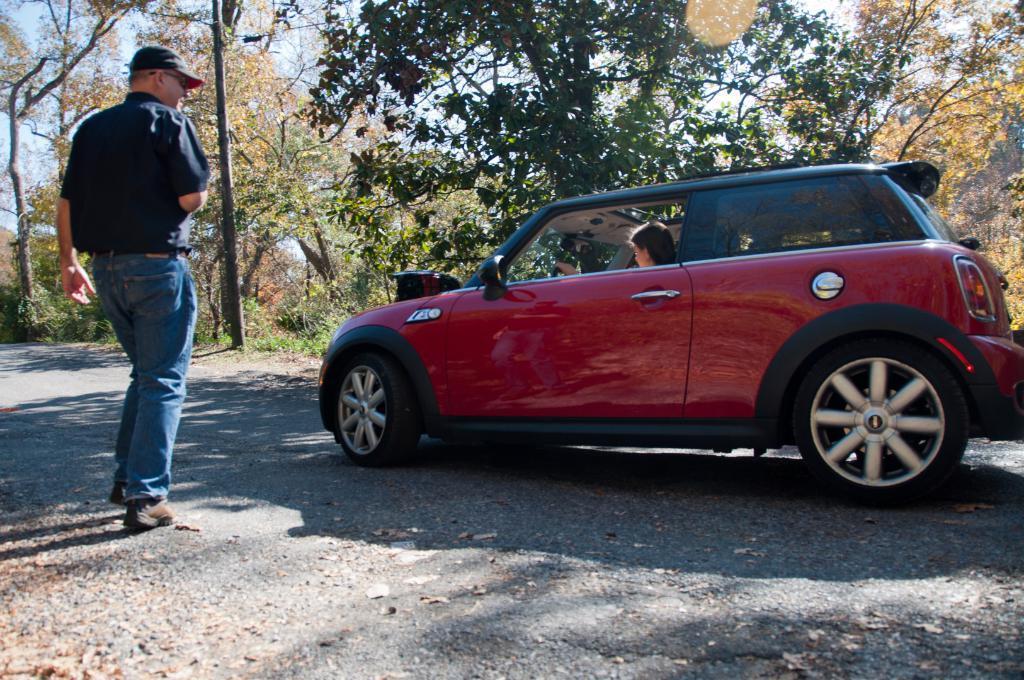How would you summarize this image in a sentence or two? In this picture we can see a red color car on the right side, there is a person sitting in the car, we can see a person walking on the left side, in the background there are some trees and a poke, we can see the sky at the top of the picture. 